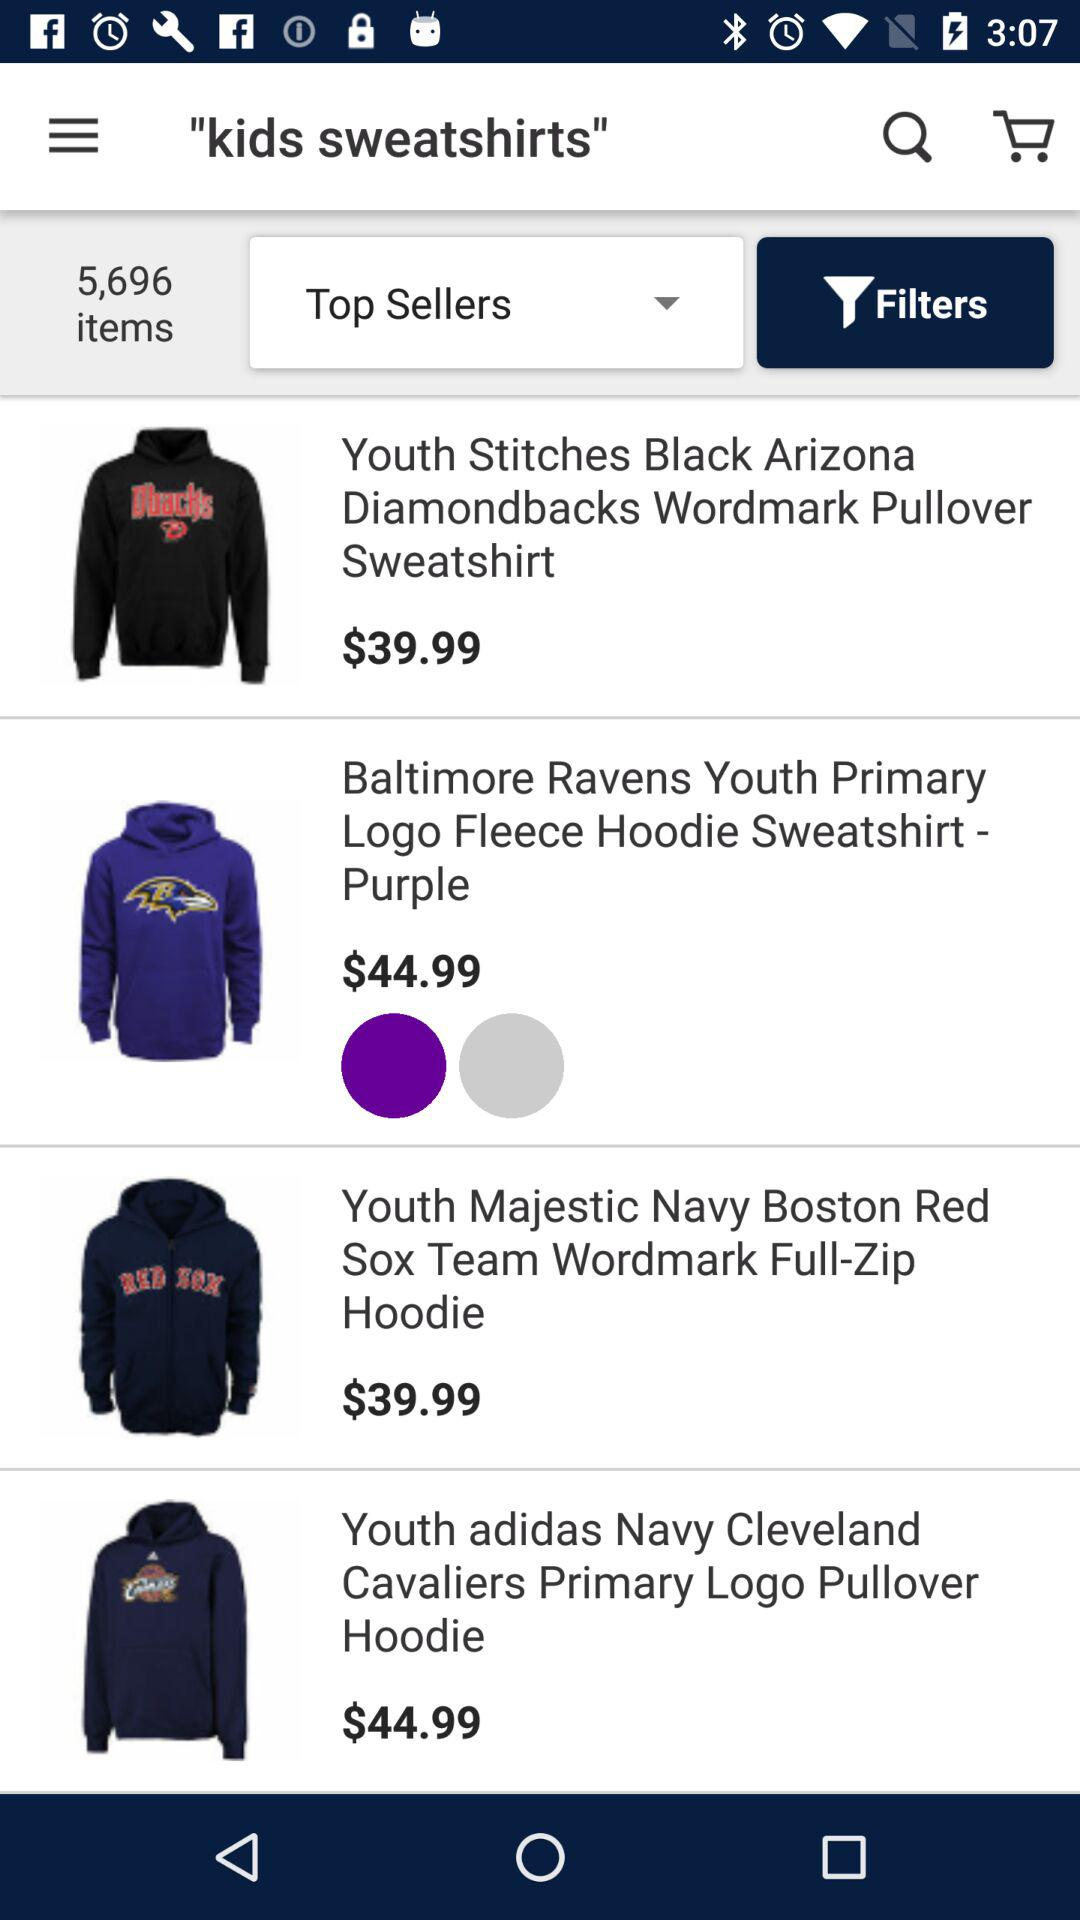How much more does the Cleveland Cavaliers hoodie cost than the Diamondbacks hoodie?
Answer the question using a single word or phrase. $5.00 